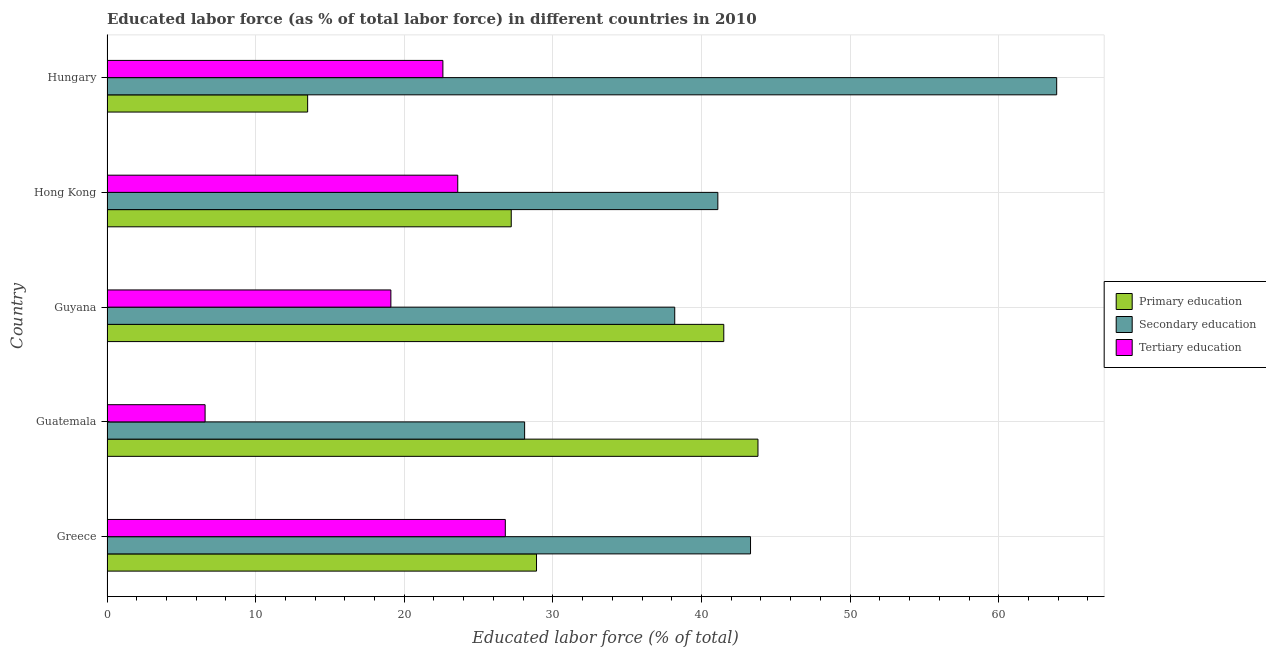How many different coloured bars are there?
Provide a short and direct response. 3. How many groups of bars are there?
Give a very brief answer. 5. Are the number of bars per tick equal to the number of legend labels?
Offer a terse response. Yes. Are the number of bars on each tick of the Y-axis equal?
Your answer should be very brief. Yes. How many bars are there on the 4th tick from the bottom?
Offer a terse response. 3. What is the label of the 1st group of bars from the top?
Keep it short and to the point. Hungary. In how many cases, is the number of bars for a given country not equal to the number of legend labels?
Offer a very short reply. 0. What is the percentage of labor force who received secondary education in Greece?
Your response must be concise. 43.3. Across all countries, what is the maximum percentage of labor force who received primary education?
Make the answer very short. 43.8. In which country was the percentage of labor force who received secondary education maximum?
Offer a very short reply. Hungary. In which country was the percentage of labor force who received primary education minimum?
Make the answer very short. Hungary. What is the total percentage of labor force who received primary education in the graph?
Offer a very short reply. 154.9. What is the difference between the percentage of labor force who received primary education in Guatemala and that in Hungary?
Offer a terse response. 30.3. What is the difference between the percentage of labor force who received tertiary education in Guatemala and the percentage of labor force who received secondary education in Hungary?
Give a very brief answer. -57.3. What is the average percentage of labor force who received tertiary education per country?
Offer a terse response. 19.74. What is the difference between the percentage of labor force who received tertiary education and percentage of labor force who received primary education in Guyana?
Make the answer very short. -22.4. What is the ratio of the percentage of labor force who received secondary education in Guatemala to that in Hong Kong?
Offer a terse response. 0.68. Is the difference between the percentage of labor force who received primary education in Guatemala and Guyana greater than the difference between the percentage of labor force who received secondary education in Guatemala and Guyana?
Keep it short and to the point. Yes. What is the difference between the highest and the second highest percentage of labor force who received secondary education?
Provide a short and direct response. 20.6. What is the difference between the highest and the lowest percentage of labor force who received primary education?
Your answer should be compact. 30.3. In how many countries, is the percentage of labor force who received primary education greater than the average percentage of labor force who received primary education taken over all countries?
Offer a terse response. 2. Is the sum of the percentage of labor force who received primary education in Greece and Hong Kong greater than the maximum percentage of labor force who received tertiary education across all countries?
Provide a succinct answer. Yes. What does the 2nd bar from the bottom in Guatemala represents?
Give a very brief answer. Secondary education. Is it the case that in every country, the sum of the percentage of labor force who received primary education and percentage of labor force who received secondary education is greater than the percentage of labor force who received tertiary education?
Your answer should be very brief. Yes. How many bars are there?
Your answer should be compact. 15. How many countries are there in the graph?
Provide a succinct answer. 5. What is the difference between two consecutive major ticks on the X-axis?
Offer a terse response. 10. How many legend labels are there?
Your response must be concise. 3. How are the legend labels stacked?
Ensure brevity in your answer.  Vertical. What is the title of the graph?
Your answer should be very brief. Educated labor force (as % of total labor force) in different countries in 2010. What is the label or title of the X-axis?
Make the answer very short. Educated labor force (% of total). What is the label or title of the Y-axis?
Keep it short and to the point. Country. What is the Educated labor force (% of total) in Primary education in Greece?
Provide a short and direct response. 28.9. What is the Educated labor force (% of total) in Secondary education in Greece?
Make the answer very short. 43.3. What is the Educated labor force (% of total) of Tertiary education in Greece?
Your answer should be compact. 26.8. What is the Educated labor force (% of total) in Primary education in Guatemala?
Provide a succinct answer. 43.8. What is the Educated labor force (% of total) in Secondary education in Guatemala?
Offer a very short reply. 28.1. What is the Educated labor force (% of total) of Tertiary education in Guatemala?
Ensure brevity in your answer.  6.6. What is the Educated labor force (% of total) in Primary education in Guyana?
Provide a succinct answer. 41.5. What is the Educated labor force (% of total) of Secondary education in Guyana?
Offer a very short reply. 38.2. What is the Educated labor force (% of total) of Tertiary education in Guyana?
Make the answer very short. 19.1. What is the Educated labor force (% of total) in Primary education in Hong Kong?
Keep it short and to the point. 27.2. What is the Educated labor force (% of total) of Secondary education in Hong Kong?
Keep it short and to the point. 41.1. What is the Educated labor force (% of total) in Tertiary education in Hong Kong?
Provide a short and direct response. 23.6. What is the Educated labor force (% of total) in Primary education in Hungary?
Provide a succinct answer. 13.5. What is the Educated labor force (% of total) in Secondary education in Hungary?
Make the answer very short. 63.9. What is the Educated labor force (% of total) in Tertiary education in Hungary?
Keep it short and to the point. 22.6. Across all countries, what is the maximum Educated labor force (% of total) in Primary education?
Make the answer very short. 43.8. Across all countries, what is the maximum Educated labor force (% of total) in Secondary education?
Your answer should be compact. 63.9. Across all countries, what is the maximum Educated labor force (% of total) in Tertiary education?
Your response must be concise. 26.8. Across all countries, what is the minimum Educated labor force (% of total) in Primary education?
Provide a succinct answer. 13.5. Across all countries, what is the minimum Educated labor force (% of total) of Secondary education?
Your response must be concise. 28.1. Across all countries, what is the minimum Educated labor force (% of total) of Tertiary education?
Give a very brief answer. 6.6. What is the total Educated labor force (% of total) of Primary education in the graph?
Offer a terse response. 154.9. What is the total Educated labor force (% of total) in Secondary education in the graph?
Offer a very short reply. 214.6. What is the total Educated labor force (% of total) in Tertiary education in the graph?
Provide a succinct answer. 98.7. What is the difference between the Educated labor force (% of total) in Primary education in Greece and that in Guatemala?
Your answer should be compact. -14.9. What is the difference between the Educated labor force (% of total) in Secondary education in Greece and that in Guatemala?
Your answer should be compact. 15.2. What is the difference between the Educated labor force (% of total) in Tertiary education in Greece and that in Guatemala?
Offer a terse response. 20.2. What is the difference between the Educated labor force (% of total) in Primary education in Greece and that in Guyana?
Ensure brevity in your answer.  -12.6. What is the difference between the Educated labor force (% of total) in Secondary education in Greece and that in Guyana?
Your answer should be very brief. 5.1. What is the difference between the Educated labor force (% of total) of Tertiary education in Greece and that in Guyana?
Offer a terse response. 7.7. What is the difference between the Educated labor force (% of total) in Primary education in Greece and that in Hong Kong?
Your answer should be compact. 1.7. What is the difference between the Educated labor force (% of total) of Primary education in Greece and that in Hungary?
Ensure brevity in your answer.  15.4. What is the difference between the Educated labor force (% of total) of Secondary education in Greece and that in Hungary?
Make the answer very short. -20.6. What is the difference between the Educated labor force (% of total) in Secondary education in Guatemala and that in Guyana?
Offer a very short reply. -10.1. What is the difference between the Educated labor force (% of total) of Primary education in Guatemala and that in Hong Kong?
Your answer should be compact. 16.6. What is the difference between the Educated labor force (% of total) of Tertiary education in Guatemala and that in Hong Kong?
Your answer should be very brief. -17. What is the difference between the Educated labor force (% of total) of Primary education in Guatemala and that in Hungary?
Your answer should be very brief. 30.3. What is the difference between the Educated labor force (% of total) of Secondary education in Guatemala and that in Hungary?
Make the answer very short. -35.8. What is the difference between the Educated labor force (% of total) in Primary education in Guyana and that in Hong Kong?
Make the answer very short. 14.3. What is the difference between the Educated labor force (% of total) of Tertiary education in Guyana and that in Hong Kong?
Your answer should be compact. -4.5. What is the difference between the Educated labor force (% of total) of Primary education in Guyana and that in Hungary?
Your response must be concise. 28. What is the difference between the Educated labor force (% of total) of Secondary education in Guyana and that in Hungary?
Make the answer very short. -25.7. What is the difference between the Educated labor force (% of total) of Tertiary education in Guyana and that in Hungary?
Ensure brevity in your answer.  -3.5. What is the difference between the Educated labor force (% of total) in Secondary education in Hong Kong and that in Hungary?
Provide a succinct answer. -22.8. What is the difference between the Educated labor force (% of total) in Tertiary education in Hong Kong and that in Hungary?
Offer a very short reply. 1. What is the difference between the Educated labor force (% of total) in Primary education in Greece and the Educated labor force (% of total) in Tertiary education in Guatemala?
Your answer should be compact. 22.3. What is the difference between the Educated labor force (% of total) in Secondary education in Greece and the Educated labor force (% of total) in Tertiary education in Guatemala?
Offer a terse response. 36.7. What is the difference between the Educated labor force (% of total) in Primary education in Greece and the Educated labor force (% of total) in Secondary education in Guyana?
Your answer should be compact. -9.3. What is the difference between the Educated labor force (% of total) of Secondary education in Greece and the Educated labor force (% of total) of Tertiary education in Guyana?
Provide a succinct answer. 24.2. What is the difference between the Educated labor force (% of total) in Secondary education in Greece and the Educated labor force (% of total) in Tertiary education in Hong Kong?
Your response must be concise. 19.7. What is the difference between the Educated labor force (% of total) of Primary education in Greece and the Educated labor force (% of total) of Secondary education in Hungary?
Ensure brevity in your answer.  -35. What is the difference between the Educated labor force (% of total) in Primary education in Greece and the Educated labor force (% of total) in Tertiary education in Hungary?
Offer a very short reply. 6.3. What is the difference between the Educated labor force (% of total) of Secondary education in Greece and the Educated labor force (% of total) of Tertiary education in Hungary?
Offer a terse response. 20.7. What is the difference between the Educated labor force (% of total) of Primary education in Guatemala and the Educated labor force (% of total) of Secondary education in Guyana?
Your answer should be very brief. 5.6. What is the difference between the Educated labor force (% of total) in Primary education in Guatemala and the Educated labor force (% of total) in Tertiary education in Guyana?
Your response must be concise. 24.7. What is the difference between the Educated labor force (% of total) in Primary education in Guatemala and the Educated labor force (% of total) in Tertiary education in Hong Kong?
Provide a short and direct response. 20.2. What is the difference between the Educated labor force (% of total) in Secondary education in Guatemala and the Educated labor force (% of total) in Tertiary education in Hong Kong?
Give a very brief answer. 4.5. What is the difference between the Educated labor force (% of total) of Primary education in Guatemala and the Educated labor force (% of total) of Secondary education in Hungary?
Give a very brief answer. -20.1. What is the difference between the Educated labor force (% of total) of Primary education in Guatemala and the Educated labor force (% of total) of Tertiary education in Hungary?
Make the answer very short. 21.2. What is the difference between the Educated labor force (% of total) in Primary education in Guyana and the Educated labor force (% of total) in Secondary education in Hong Kong?
Ensure brevity in your answer.  0.4. What is the difference between the Educated labor force (% of total) of Primary education in Guyana and the Educated labor force (% of total) of Tertiary education in Hong Kong?
Your answer should be compact. 17.9. What is the difference between the Educated labor force (% of total) of Secondary education in Guyana and the Educated labor force (% of total) of Tertiary education in Hong Kong?
Keep it short and to the point. 14.6. What is the difference between the Educated labor force (% of total) in Primary education in Guyana and the Educated labor force (% of total) in Secondary education in Hungary?
Your answer should be very brief. -22.4. What is the difference between the Educated labor force (% of total) in Primary education in Guyana and the Educated labor force (% of total) in Tertiary education in Hungary?
Your answer should be very brief. 18.9. What is the difference between the Educated labor force (% of total) in Secondary education in Guyana and the Educated labor force (% of total) in Tertiary education in Hungary?
Give a very brief answer. 15.6. What is the difference between the Educated labor force (% of total) of Primary education in Hong Kong and the Educated labor force (% of total) of Secondary education in Hungary?
Provide a short and direct response. -36.7. What is the average Educated labor force (% of total) in Primary education per country?
Your response must be concise. 30.98. What is the average Educated labor force (% of total) of Secondary education per country?
Your answer should be very brief. 42.92. What is the average Educated labor force (% of total) of Tertiary education per country?
Provide a short and direct response. 19.74. What is the difference between the Educated labor force (% of total) in Primary education and Educated labor force (% of total) in Secondary education in Greece?
Make the answer very short. -14.4. What is the difference between the Educated labor force (% of total) in Primary education and Educated labor force (% of total) in Tertiary education in Guatemala?
Make the answer very short. 37.2. What is the difference between the Educated labor force (% of total) in Secondary education and Educated labor force (% of total) in Tertiary education in Guatemala?
Offer a very short reply. 21.5. What is the difference between the Educated labor force (% of total) of Primary education and Educated labor force (% of total) of Tertiary education in Guyana?
Provide a short and direct response. 22.4. What is the difference between the Educated labor force (% of total) in Secondary education and Educated labor force (% of total) in Tertiary education in Guyana?
Provide a succinct answer. 19.1. What is the difference between the Educated labor force (% of total) of Primary education and Educated labor force (% of total) of Tertiary education in Hong Kong?
Provide a succinct answer. 3.6. What is the difference between the Educated labor force (% of total) in Primary education and Educated labor force (% of total) in Secondary education in Hungary?
Offer a terse response. -50.4. What is the difference between the Educated labor force (% of total) of Secondary education and Educated labor force (% of total) of Tertiary education in Hungary?
Provide a succinct answer. 41.3. What is the ratio of the Educated labor force (% of total) of Primary education in Greece to that in Guatemala?
Your response must be concise. 0.66. What is the ratio of the Educated labor force (% of total) of Secondary education in Greece to that in Guatemala?
Provide a short and direct response. 1.54. What is the ratio of the Educated labor force (% of total) in Tertiary education in Greece to that in Guatemala?
Your answer should be very brief. 4.06. What is the ratio of the Educated labor force (% of total) of Primary education in Greece to that in Guyana?
Offer a very short reply. 0.7. What is the ratio of the Educated labor force (% of total) in Secondary education in Greece to that in Guyana?
Ensure brevity in your answer.  1.13. What is the ratio of the Educated labor force (% of total) of Tertiary education in Greece to that in Guyana?
Keep it short and to the point. 1.4. What is the ratio of the Educated labor force (% of total) of Primary education in Greece to that in Hong Kong?
Give a very brief answer. 1.06. What is the ratio of the Educated labor force (% of total) of Secondary education in Greece to that in Hong Kong?
Make the answer very short. 1.05. What is the ratio of the Educated labor force (% of total) of Tertiary education in Greece to that in Hong Kong?
Ensure brevity in your answer.  1.14. What is the ratio of the Educated labor force (% of total) in Primary education in Greece to that in Hungary?
Ensure brevity in your answer.  2.14. What is the ratio of the Educated labor force (% of total) of Secondary education in Greece to that in Hungary?
Offer a very short reply. 0.68. What is the ratio of the Educated labor force (% of total) in Tertiary education in Greece to that in Hungary?
Make the answer very short. 1.19. What is the ratio of the Educated labor force (% of total) of Primary education in Guatemala to that in Guyana?
Give a very brief answer. 1.06. What is the ratio of the Educated labor force (% of total) of Secondary education in Guatemala to that in Guyana?
Keep it short and to the point. 0.74. What is the ratio of the Educated labor force (% of total) of Tertiary education in Guatemala to that in Guyana?
Provide a succinct answer. 0.35. What is the ratio of the Educated labor force (% of total) in Primary education in Guatemala to that in Hong Kong?
Offer a terse response. 1.61. What is the ratio of the Educated labor force (% of total) in Secondary education in Guatemala to that in Hong Kong?
Provide a short and direct response. 0.68. What is the ratio of the Educated labor force (% of total) in Tertiary education in Guatemala to that in Hong Kong?
Your response must be concise. 0.28. What is the ratio of the Educated labor force (% of total) of Primary education in Guatemala to that in Hungary?
Ensure brevity in your answer.  3.24. What is the ratio of the Educated labor force (% of total) of Secondary education in Guatemala to that in Hungary?
Offer a very short reply. 0.44. What is the ratio of the Educated labor force (% of total) of Tertiary education in Guatemala to that in Hungary?
Give a very brief answer. 0.29. What is the ratio of the Educated labor force (% of total) in Primary education in Guyana to that in Hong Kong?
Offer a very short reply. 1.53. What is the ratio of the Educated labor force (% of total) in Secondary education in Guyana to that in Hong Kong?
Offer a very short reply. 0.93. What is the ratio of the Educated labor force (% of total) of Tertiary education in Guyana to that in Hong Kong?
Provide a short and direct response. 0.81. What is the ratio of the Educated labor force (% of total) in Primary education in Guyana to that in Hungary?
Offer a terse response. 3.07. What is the ratio of the Educated labor force (% of total) in Secondary education in Guyana to that in Hungary?
Provide a short and direct response. 0.6. What is the ratio of the Educated labor force (% of total) in Tertiary education in Guyana to that in Hungary?
Make the answer very short. 0.85. What is the ratio of the Educated labor force (% of total) in Primary education in Hong Kong to that in Hungary?
Offer a terse response. 2.01. What is the ratio of the Educated labor force (% of total) in Secondary education in Hong Kong to that in Hungary?
Provide a succinct answer. 0.64. What is the ratio of the Educated labor force (% of total) of Tertiary education in Hong Kong to that in Hungary?
Provide a succinct answer. 1.04. What is the difference between the highest and the second highest Educated labor force (% of total) of Primary education?
Make the answer very short. 2.3. What is the difference between the highest and the second highest Educated labor force (% of total) in Secondary education?
Give a very brief answer. 20.6. What is the difference between the highest and the lowest Educated labor force (% of total) in Primary education?
Keep it short and to the point. 30.3. What is the difference between the highest and the lowest Educated labor force (% of total) in Secondary education?
Make the answer very short. 35.8. What is the difference between the highest and the lowest Educated labor force (% of total) in Tertiary education?
Provide a succinct answer. 20.2. 